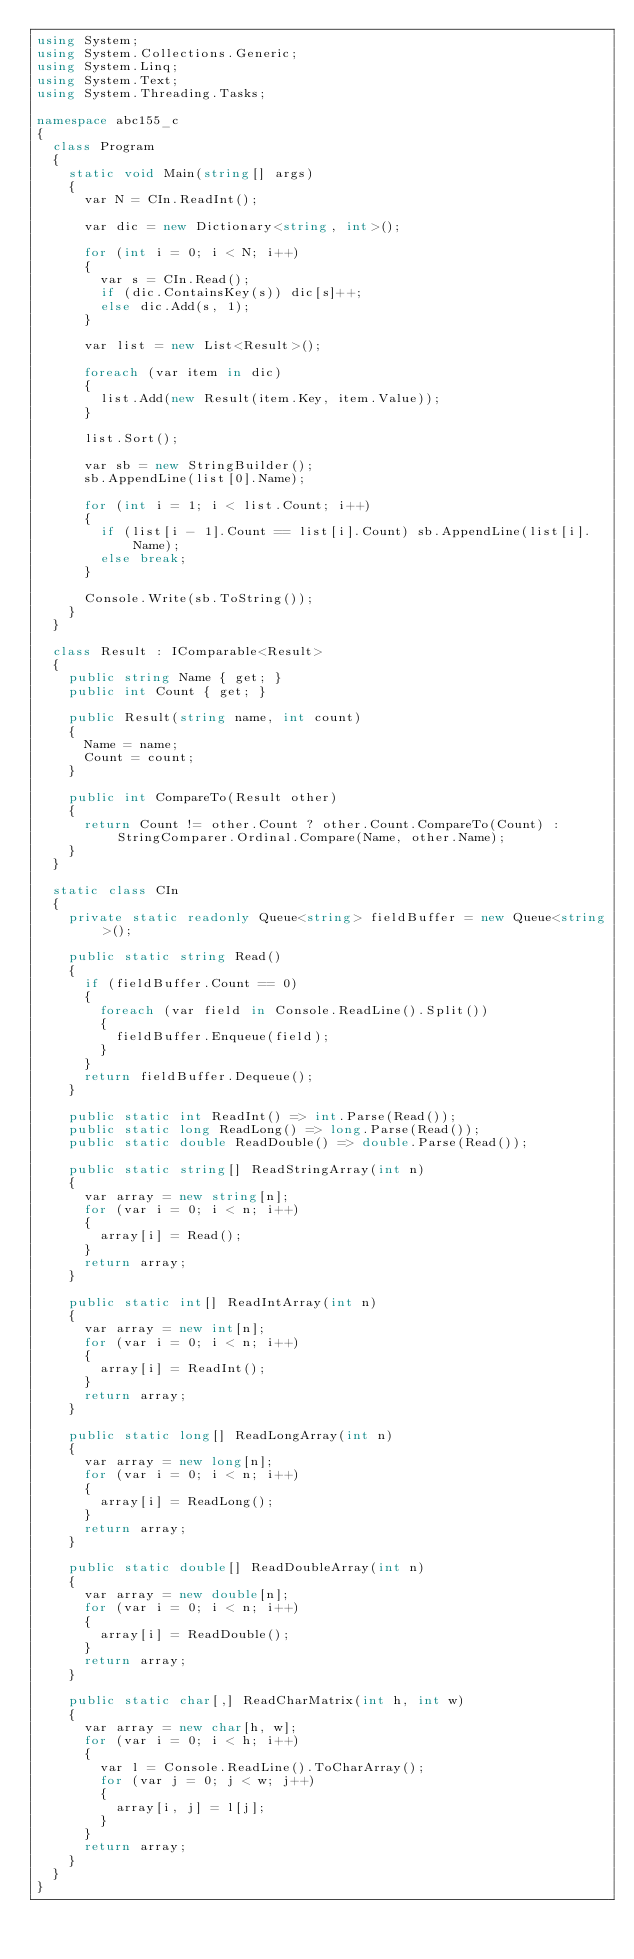Convert code to text. <code><loc_0><loc_0><loc_500><loc_500><_C#_>using System;
using System.Collections.Generic;
using System.Linq;
using System.Text;
using System.Threading.Tasks;

namespace abc155_c
{
  class Program
  {
    static void Main(string[] args)
    {
      var N = CIn.ReadInt();

      var dic = new Dictionary<string, int>();

      for (int i = 0; i < N; i++)
      {
        var s = CIn.Read();
        if (dic.ContainsKey(s)) dic[s]++;
        else dic.Add(s, 1);
      }

      var list = new List<Result>();

      foreach (var item in dic)
      {
        list.Add(new Result(item.Key, item.Value));
      }

      list.Sort();

      var sb = new StringBuilder();
      sb.AppendLine(list[0].Name);

      for (int i = 1; i < list.Count; i++)
      {
        if (list[i - 1].Count == list[i].Count) sb.AppendLine(list[i].Name);
        else break;
      }

      Console.Write(sb.ToString());
    }
  }

  class Result : IComparable<Result>
  {
    public string Name { get; }
    public int Count { get; }

    public Result(string name, int count)
    {
      Name = name;
      Count = count;
    }

    public int CompareTo(Result other)
    {
      return Count != other.Count ? other.Count.CompareTo(Count) : StringComparer.Ordinal.Compare(Name, other.Name);
    }
  }

  static class CIn
  {
    private static readonly Queue<string> fieldBuffer = new Queue<string>();

    public static string Read()
    {
      if (fieldBuffer.Count == 0)
      {
        foreach (var field in Console.ReadLine().Split())
        {
          fieldBuffer.Enqueue(field);
        }
      }
      return fieldBuffer.Dequeue();
    }

    public static int ReadInt() => int.Parse(Read());
    public static long ReadLong() => long.Parse(Read());
    public static double ReadDouble() => double.Parse(Read());

    public static string[] ReadStringArray(int n)
    {
      var array = new string[n];
      for (var i = 0; i < n; i++)
      {
        array[i] = Read();
      }
      return array;
    }

    public static int[] ReadIntArray(int n)
    {
      var array = new int[n];
      for (var i = 0; i < n; i++)
      {
        array[i] = ReadInt();
      }
      return array;
    }

    public static long[] ReadLongArray(int n)
    {
      var array = new long[n];
      for (var i = 0; i < n; i++)
      {
        array[i] = ReadLong();
      }
      return array;
    }

    public static double[] ReadDoubleArray(int n)
    {
      var array = new double[n];
      for (var i = 0; i < n; i++)
      {
        array[i] = ReadDouble();
      }
      return array;
    }

    public static char[,] ReadCharMatrix(int h, int w)
    {
      var array = new char[h, w];
      for (var i = 0; i < h; i++)
      {
        var l = Console.ReadLine().ToCharArray();
        for (var j = 0; j < w; j++)
        {
          array[i, j] = l[j];
        }
      }
      return array;
    }
  }
}</code> 